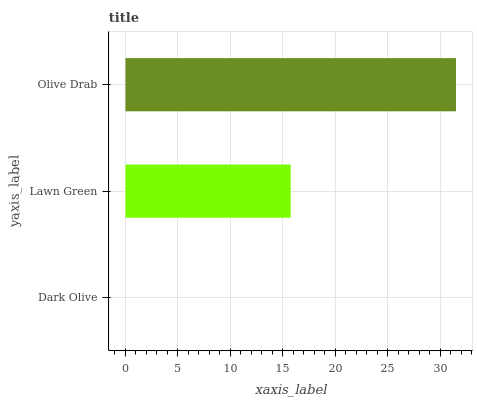Is Dark Olive the minimum?
Answer yes or no. Yes. Is Olive Drab the maximum?
Answer yes or no. Yes. Is Lawn Green the minimum?
Answer yes or no. No. Is Lawn Green the maximum?
Answer yes or no. No. Is Lawn Green greater than Dark Olive?
Answer yes or no. Yes. Is Dark Olive less than Lawn Green?
Answer yes or no. Yes. Is Dark Olive greater than Lawn Green?
Answer yes or no. No. Is Lawn Green less than Dark Olive?
Answer yes or no. No. Is Lawn Green the high median?
Answer yes or no. Yes. Is Lawn Green the low median?
Answer yes or no. Yes. Is Olive Drab the high median?
Answer yes or no. No. Is Olive Drab the low median?
Answer yes or no. No. 